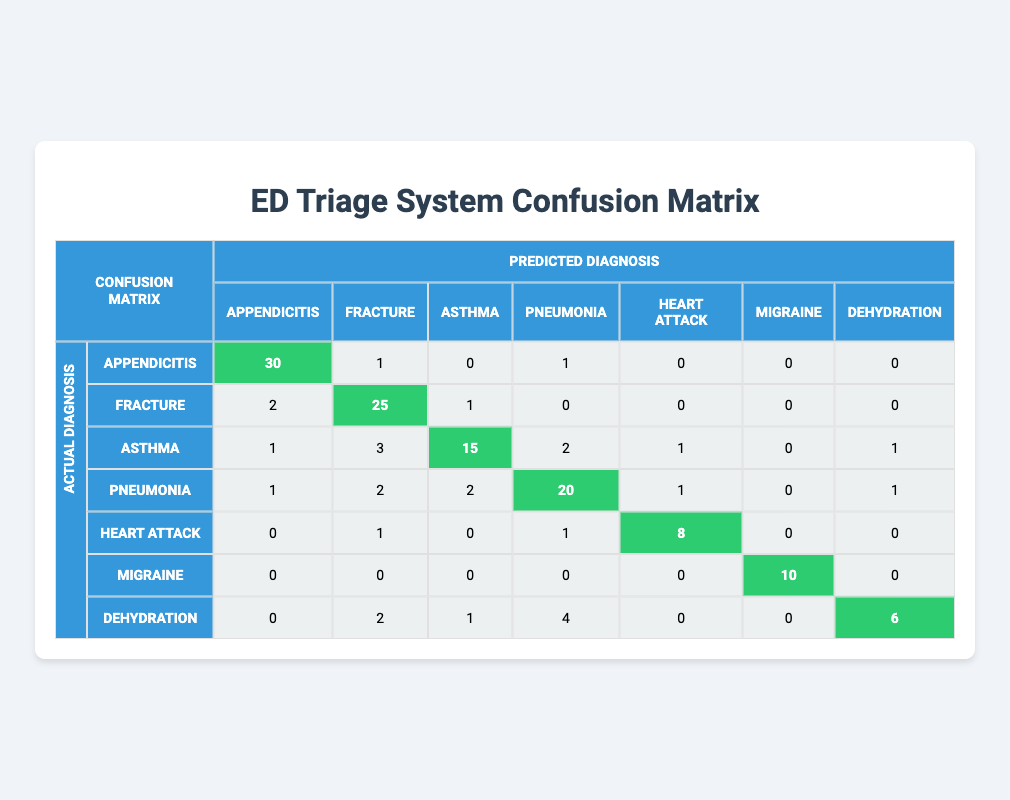What is the number of true diagnoses for Pneumonia? Referring to the row for Pneumonia, the true diagnoses are represented by the diagonal value, which is 20. This indicates that 20 cases of Pneumonia were correctly diagnosed.
Answer: 20 What is the total number of diagnoses predicted as Fracture? To find the total predicted diagnoses for Fracture, sum all values in the Fracture column: 2 (Appendicitis) + 25 (Fracture) + 1 (Asthma) + 0 (Pneumonia) + 1 (Heart Attack) + 0 (Migraine) + 2 (Dehydration) = 31.
Answer: 31 Is there a higher number of true diagnoses for Dehydration compared to Asthma? Checking the diagonal values, Dehydration has 6 true diagnoses, while Asthma has 15 true diagnoses. Since 6 < 15, we conclude that there are fewer true diagnoses for Dehydration compared to Asthma.
Answer: No What is the total number of false positives for Appendicitis? For false positives in the Appendicitis diagnosis, we consider all the cases in the Appendicitis column that are not the true diagnosis (30). Therefore, false positives are 2 (Fracture) + 1 (Asthma) + 1 (Pneumonia) + 0 (Heart Attack) + 0 (Migraine) + 0 (Dehydration) = 4.
Answer: 4 What is the average number of diagnoses for Heart Attack? To find the average, sum all values in the Heart Attack row (0 + 1 + 0 + 1 + 8 + 0 + 0 = 10) and divide by the number of conditions (7). The average is 10/7, which equals approximately 1.43.
Answer: 1.43 How many cases of migraine were mistaken for Dehydration? Looking at the Migraine row, we can see that 0 cases of Migraine were mistaken for Dehydration, hence the value corresponding to Dehydration under the Migraine category.
Answer: 0 Which condition had the highest number of true diagnoses? We compare the diagonal values: Appendicitis (30), Fracture (25), Asthma (15), Pneumonia (20), Heart Attack (8), Migraine (10), and Dehydration (6). The highest value is for Appendicitis at 30.
Answer: Appendicitis If we consider the false negatives for Asthma, how many cases were misdiagnosed? The false negatives for Asthma are calculated by adding all the non-Asthma predicted values in its row: 1 (Appendicitis) + 3 (Fracture) + 2 (Pneumonia) + 1 (Heart Attack) + 0 (Migraine) + 1 (Dehydration) = 8. Thus, 8 cases were misdiagnosed.
Answer: 8 